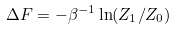Convert formula to latex. <formula><loc_0><loc_0><loc_500><loc_500>\Delta F = - \beta ^ { - 1 } \ln ( Z _ { 1 } / Z _ { 0 } )</formula> 